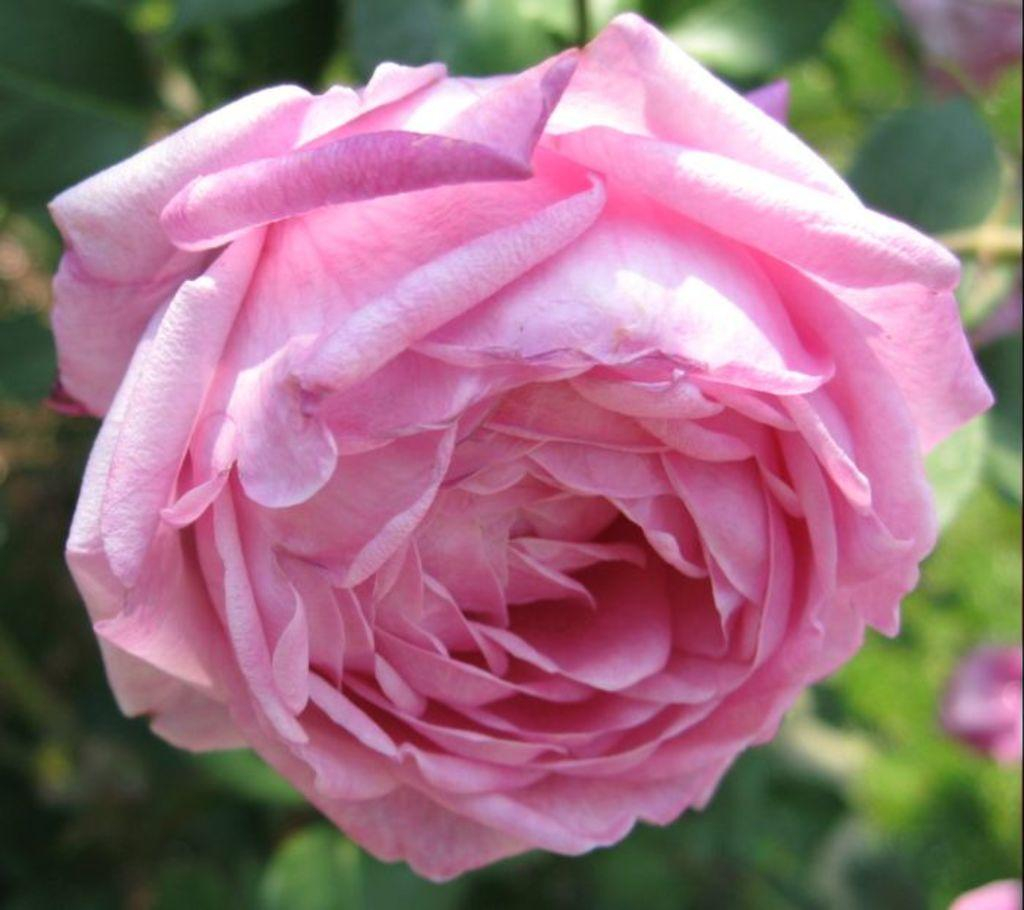What type of flower is in the image? There is a pink rose flower in the image. What can be seen in the background of the image? The background of the image includes plants with flowers and leaves. What type of test is being conducted in the image? There is no test being conducted in the image; it features a pink rose flower and plants in the background. 